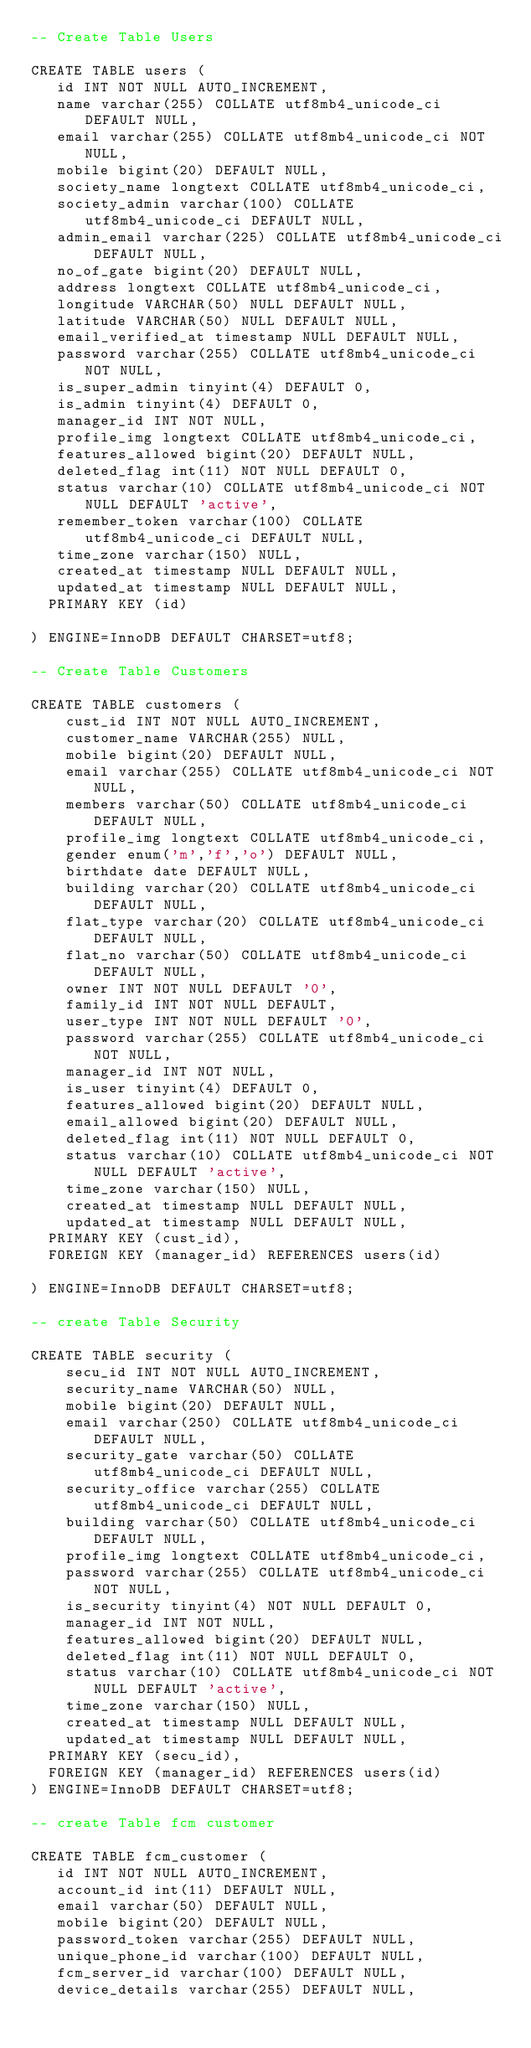Convert code to text. <code><loc_0><loc_0><loc_500><loc_500><_SQL_>-- Create Table Users

CREATE TABLE users (
   id INT NOT NULL AUTO_INCREMENT,
   name varchar(255) COLLATE utf8mb4_unicode_ci DEFAULT NULL,
   email varchar(255) COLLATE utf8mb4_unicode_ci NOT NULL,
   mobile bigint(20) DEFAULT NULL,
   society_name longtext COLLATE utf8mb4_unicode_ci,
   society_admin varchar(100) COLLATE utf8mb4_unicode_ci DEFAULT NULL,
   admin_email varchar(225) COLLATE utf8mb4_unicode_ci DEFAULT NULL,
   no_of_gate bigint(20) DEFAULT NULL,
   address longtext COLLATE utf8mb4_unicode_ci,
   longitude VARCHAR(50) NULL DEFAULT NULL,
   latitude VARCHAR(50) NULL DEFAULT NULL,
   email_verified_at timestamp NULL DEFAULT NULL,
   password varchar(255) COLLATE utf8mb4_unicode_ci NOT NULL,
   is_super_admin tinyint(4) DEFAULT 0,
   is_admin tinyint(4) DEFAULT 0,
   manager_id INT NOT NULL,
   profile_img longtext COLLATE utf8mb4_unicode_ci,
   features_allowed bigint(20) DEFAULT NULL,
   deleted_flag int(11) NOT NULL DEFAULT 0,
   status varchar(10) COLLATE utf8mb4_unicode_ci NOT NULL DEFAULT 'active',
   remember_token varchar(100) COLLATE utf8mb4_unicode_ci DEFAULT NULL,
   time_zone varchar(150) NULL,
   created_at timestamp NULL DEFAULT NULL,
   updated_at timestamp NULL DEFAULT NULL,
  PRIMARY KEY (id)

) ENGINE=InnoDB DEFAULT CHARSET=utf8;

-- Create Table Customers

CREATE TABLE customers (
    cust_id INT NOT NULL AUTO_INCREMENT,
    customer_name VARCHAR(255) NULL,
    mobile bigint(20) DEFAULT NULL,
    email varchar(255) COLLATE utf8mb4_unicode_ci NOT NULL,
    members varchar(50) COLLATE utf8mb4_unicode_ci DEFAULT NULL,
    profile_img longtext COLLATE utf8mb4_unicode_ci,
    gender enum('m','f','o') DEFAULT NULL,
    birthdate date DEFAULT NULL,
    building varchar(20) COLLATE utf8mb4_unicode_ci DEFAULT NULL,
  	flat_type varchar(20) COLLATE utf8mb4_unicode_ci DEFAULT NULL,
  	flat_no varchar(50) COLLATE utf8mb4_unicode_ci DEFAULT NULL,
  	owner INT NOT NULL DEFAULT '0',
    family_id INT NOT NULL DEFAULT,
    user_type INT NOT NULL DEFAULT '0',
  	password varchar(255) COLLATE utf8mb4_unicode_ci NOT NULL,
  	manager_id INT NOT NULL,
  	is_user tinyint(4) DEFAULT 0,
    features_allowed bigint(20) DEFAULT NULL,
    email_allowed bigint(20) DEFAULT NULL,
   	deleted_flag int(11) NOT NULL DEFAULT 0,
    status varchar(10) COLLATE utf8mb4_unicode_ci NOT NULL DEFAULT 'active',
    time_zone varchar(150) NULL,
    created_at timestamp NULL DEFAULT NULL,
    updated_at timestamp NULL DEFAULT NULL,
  PRIMARY KEY (cust_id),
  FOREIGN KEY (manager_id) REFERENCES users(id)

) ENGINE=InnoDB DEFAULT CHARSET=utf8; 

-- create Table Security

CREATE TABLE security (
	  secu_id INT NOT NULL AUTO_INCREMENT,
    security_name VARCHAR(50) NULL,
    mobile bigint(20) DEFAULT NULL,
    email varchar(250) COLLATE utf8mb4_unicode_ci DEFAULT NULL,
 	  security_gate varchar(50) COLLATE utf8mb4_unicode_ci DEFAULT NULL,
    security_office varchar(255) COLLATE utf8mb4_unicode_ci DEFAULT NULL,
    building varchar(50) COLLATE utf8mb4_unicode_ci DEFAULT NULL,
    profile_img longtext COLLATE utf8mb4_unicode_ci,
  	password varchar(255) COLLATE utf8mb4_unicode_ci NOT NULL,
  	is_security tinyint(4) NOT NULL DEFAULT 0,
    manager_id INT NOT NULL,
    features_allowed bigint(20) DEFAULT NULL,
   	deleted_flag int(11) NOT NULL DEFAULT 0,
    status varchar(10) COLLATE utf8mb4_unicode_ci NOT NULL DEFAULT 'active',
    time_zone varchar(150) NULL,
    created_at timestamp NULL DEFAULT NULL,
    updated_at timestamp NULL DEFAULT NULL,
  PRIMARY KEY (secu_id),
  FOREIGN KEY (manager_id) REFERENCES users(id)
) ENGINE=InnoDB DEFAULT CHARSET=utf8; 

-- create Table fcm customer

CREATE TABLE fcm_customer (
   id INT NOT NULL AUTO_INCREMENT,
   account_id int(11) DEFAULT NULL,
   email varchar(50) DEFAULT NULL,
   mobile bigint(20) DEFAULT NULL,
   password_token varchar(255) DEFAULT NULL,
   unique_phone_id varchar(100) DEFAULT NULL,
   fcm_server_id varchar(100) DEFAULT NULL,
   device_details varchar(255) DEFAULT NULL,</code> 